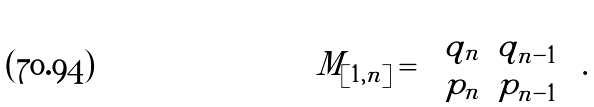Convert formula to latex. <formula><loc_0><loc_0><loc_500><loc_500>M _ { [ 1 , n ] } = \left ( \begin{matrix} q _ { n } & q _ { n - 1 } \\ p _ { n } & p _ { n - 1 } \end{matrix} \right ) .</formula> 